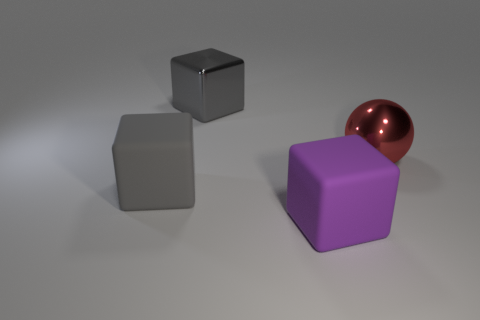Does the sphere have the same material as the big purple cube?
Provide a succinct answer. No. What shape is the metal thing to the right of the large purple block?
Your answer should be compact. Sphere. There is a large rubber thing that is behind the purple object; are there any metal things that are behind it?
Keep it short and to the point. Yes. Are there any purple metal cubes that have the same size as the red metallic thing?
Make the answer very short. No. There is a cube left of the large gray shiny object; is it the same color as the big metallic cube?
Provide a succinct answer. Yes. The ball is what size?
Your answer should be very brief. Large. What size is the metallic block behind the big cube that is to the left of the gray metal block?
Keep it short and to the point. Large. What number of things have the same color as the big metal sphere?
Your answer should be compact. 0. How many large purple matte blocks are there?
Provide a succinct answer. 1. What number of objects have the same material as the big purple cube?
Offer a terse response. 1. 